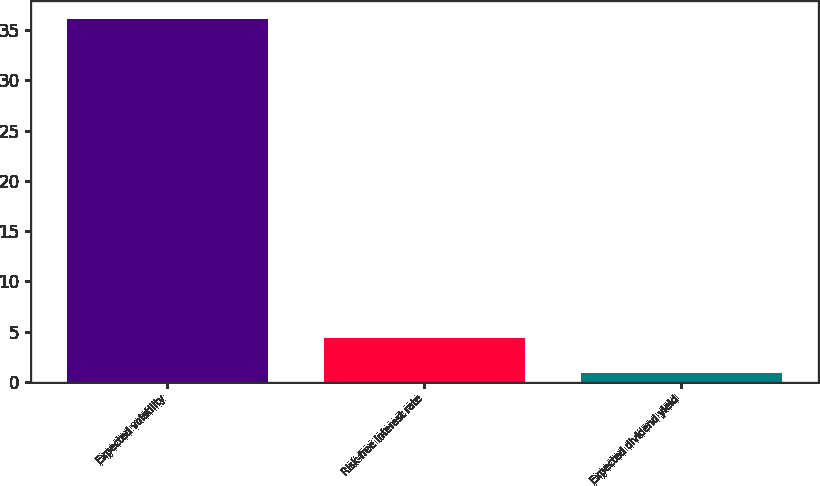Convert chart. <chart><loc_0><loc_0><loc_500><loc_500><bar_chart><fcel>Expected volatility<fcel>Risk-free interest rate<fcel>Expected dividend yield<nl><fcel>36.07<fcel>4.4<fcel>0.88<nl></chart> 